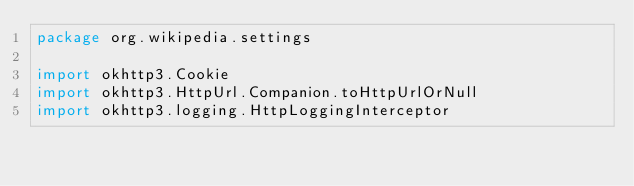<code> <loc_0><loc_0><loc_500><loc_500><_Kotlin_>package org.wikipedia.settings

import okhttp3.Cookie
import okhttp3.HttpUrl.Companion.toHttpUrlOrNull
import okhttp3.logging.HttpLoggingInterceptor</code> 